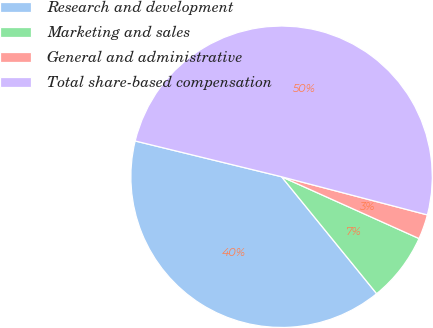Convert chart. <chart><loc_0><loc_0><loc_500><loc_500><pie_chart><fcel>Research and development<fcel>Marketing and sales<fcel>General and administrative<fcel>Total share-based compensation<nl><fcel>39.68%<fcel>7.41%<fcel>2.65%<fcel>50.26%<nl></chart> 